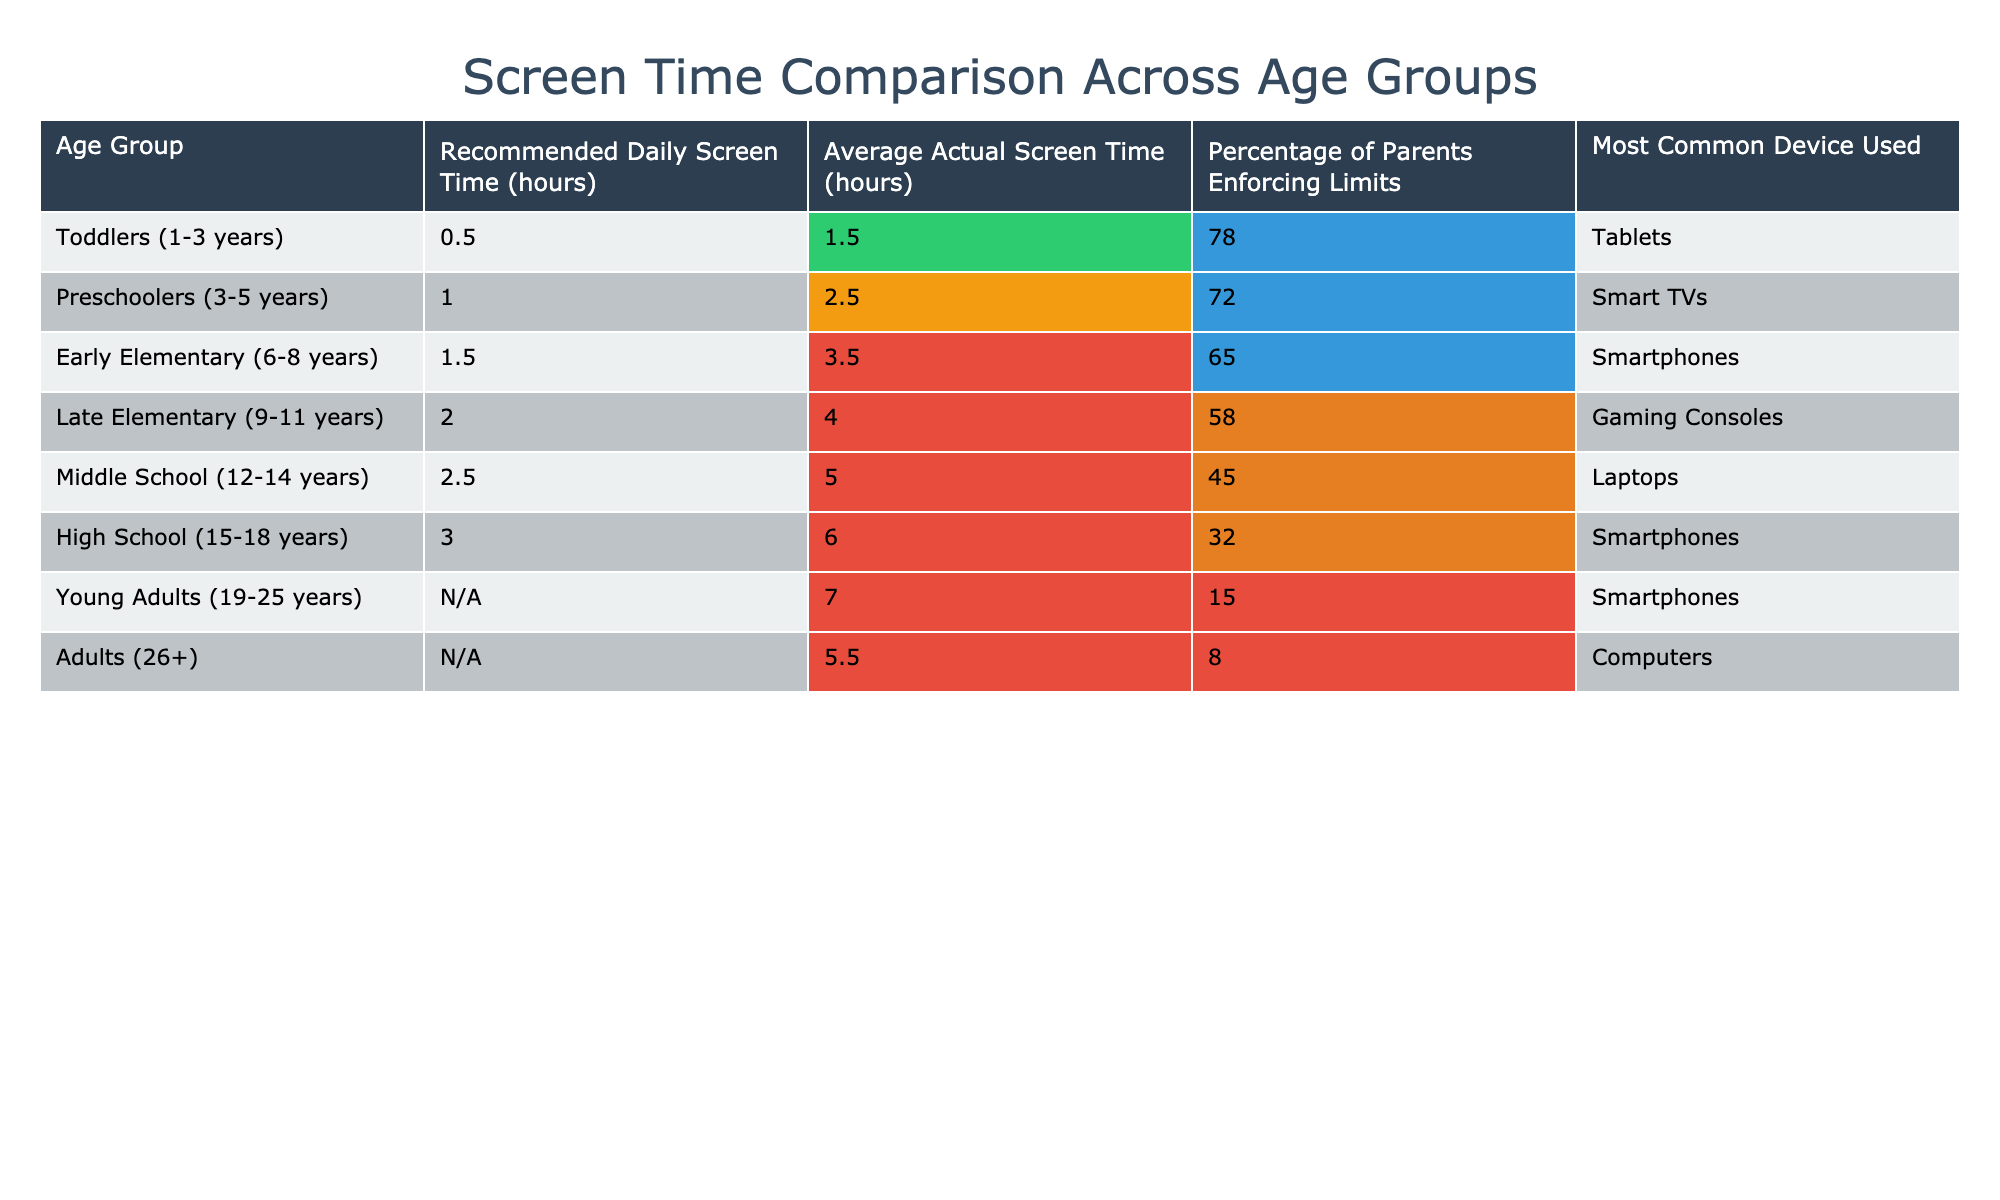What is the recommended daily screen time for preschoolers? The table indicates that preschoolers (ages 3-5 years) have a recommended daily screen time of 1 hour.
Answer: 1 hour Which age group has the highest average actual screen time? The age group with the highest average actual screen time is Young Adults (ages 19-25) with an average of 7 hours per day.
Answer: Young Adults (19-25) What percentage of parents enforce screen time limits for toddlers? The table shows that 78% of parents enforce screen time limits for toddlers (1-3 years).
Answer: 78% Is there a recommended daily screen time limit for adults? According to the table, there is no set limit for adults (ages 26+), meaning it is marked as 'N/A'.
Answer: No What is the difference in average actual screen time between late elementary and middle school age groups? The average actual screen time for late elementary (9-11 years) is 4 hours, and for middle school (12-14 years) is 5 hours. The difference is 5 - 4 = 1 hour.
Answer: 1 hour Which device is most commonly used by preschoolers? The table lists Smart TVs as the most common device used by preschoolers (ages 3-5 years).
Answer: Smart TVs Is the percentage of parents enforcing limits higher for toddlers than for middle schoolers? The table shows 78% for toddlers and 45% for middle schoolers. Since 78% is greater than 45%, the answer is yes.
Answer: Yes Calculate the average of recommended daily screen time for early elementary and late elementary age groups. The recommended daily screen time is 1.5 hours for early elementary and 2 hours for late elementary. The average is (1.5 + 2) / 2 = 1.75 hours.
Answer: 1.75 hours What age group has the lowest percentage of parents enforcing limits? The age group with the lowest percentage of parents enforcing limits is Young Adults (19-25 years) at 15%.
Answer: Young Adults (19-25) If we were to consider all groups with recommended limits, what is the total recommended daily screen time for all age groups? Considering only groups with recommended limits: 0.5 + 1 + 1.5 + 2 + 2.5 + 3 = 10.5 hours total recommended daily screen time.
Answer: 10.5 hours 